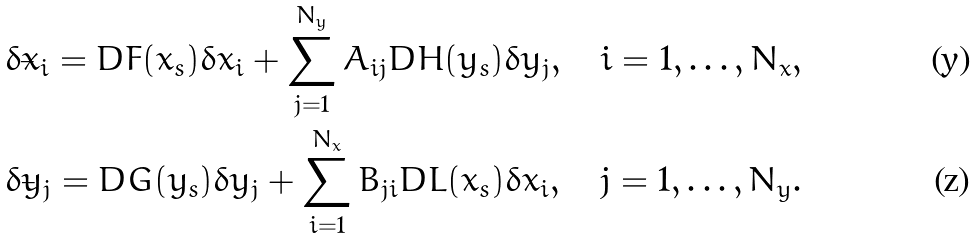<formula> <loc_0><loc_0><loc_500><loc_500>\dot { \delta x _ { i } } = D F ( x _ { s } ) \delta x _ { i } + \sum _ { j = 1 } ^ { N _ { y } } A _ { i j } D H ( y _ { s } ) \delta y _ { j } , \quad i = 1 , \dots , N _ { x } , \\ \dot { \delta y _ { j } } = D G ( y _ { s } ) \delta y _ { j } + \sum _ { i = 1 } ^ { N _ { x } } B _ { j i } D L ( x _ { s } ) \delta x _ { i } , \quad j = 1 , \dots , N _ { y } .</formula> 